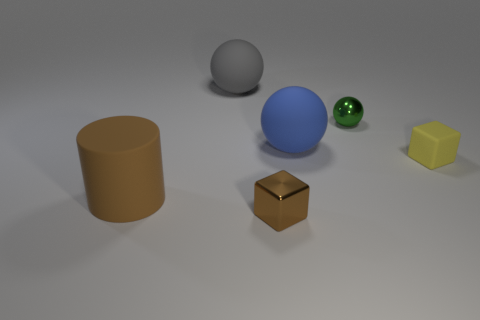There is a large object that is the same color as the small metal block; what is it made of?
Your answer should be very brief. Rubber. How many other things are the same size as the gray ball?
Provide a succinct answer. 2. The rubber cylinder is what size?
Your answer should be compact. Large. Do the ball behind the tiny green ball and the blue thing have the same material?
Provide a short and direct response. Yes. There is a tiny metallic thing that is the same shape as the big gray rubber thing; what is its color?
Offer a terse response. Green. Is the color of the small metal thing on the right side of the tiny brown thing the same as the small matte object?
Ensure brevity in your answer.  No. There is a gray sphere; are there any small metallic things on the left side of it?
Provide a short and direct response. No. There is a thing that is both in front of the big blue matte sphere and on the right side of the tiny shiny block; what is its color?
Ensure brevity in your answer.  Yellow. What is the shape of the large matte thing that is the same color as the tiny shiny block?
Provide a short and direct response. Cylinder. How big is the matte object that is behind the sphere in front of the metal ball?
Offer a terse response. Large. 